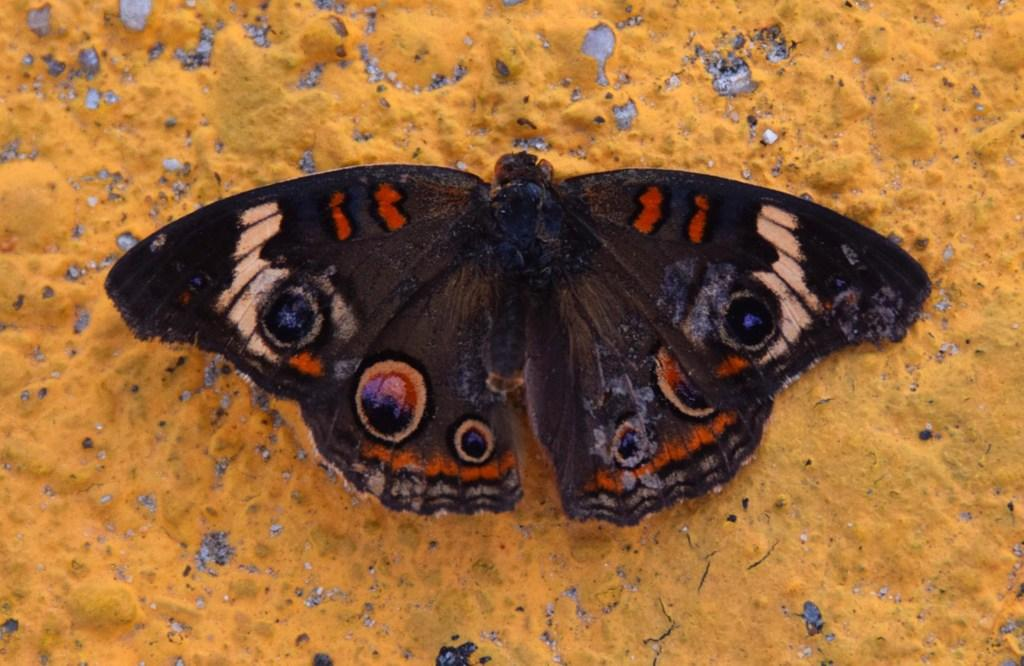What is the main subject of the picture? The main subject of the picture is a butterfly. What color is the butterfly? The butterfly is black in color. What is the butterfly resting on in the picture? The butterfly is on a yellow surface. What type of soda is the butterfly drinking in the image? There is no soda present in the image, and butterflies do not drink soda. 